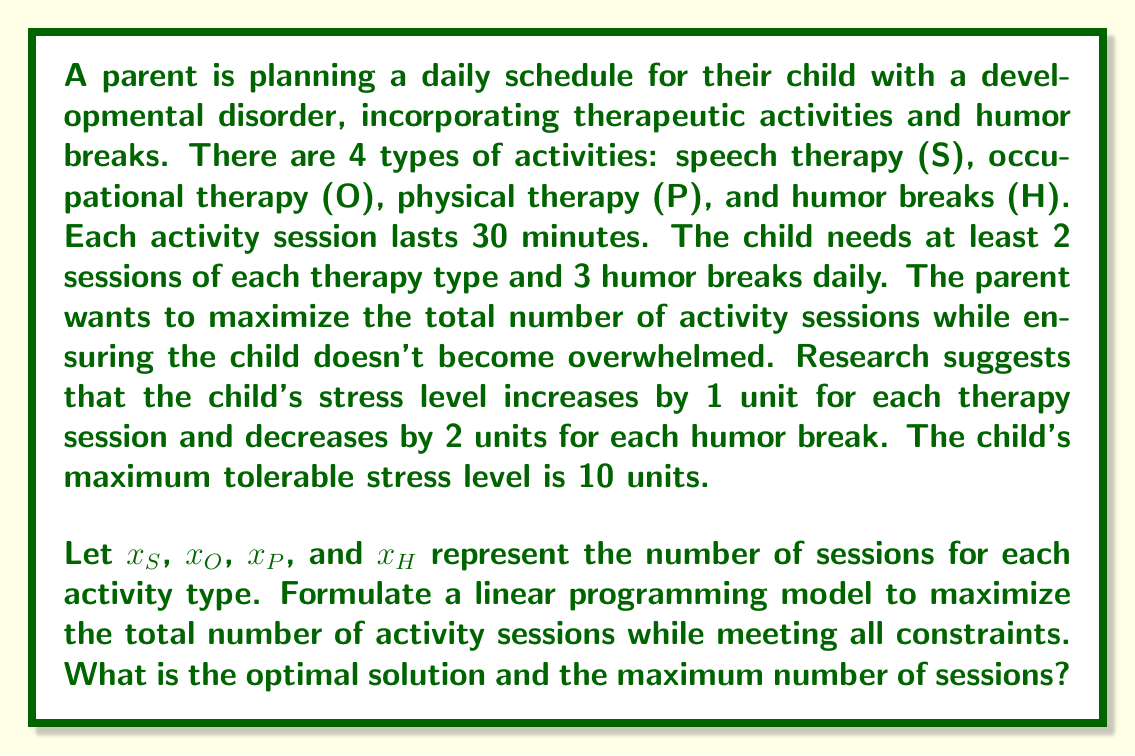Could you help me with this problem? To solve this problem, we need to set up a linear programming model:

Objective function:
Maximize $Z = x_S + x_O + x_P + x_H$

Subject to the following constraints:

1. Minimum sessions for each therapy type:
   $x_S \geq 2$
   $x_O \geq 2$
   $x_P \geq 2$

2. Minimum humor breaks:
   $x_H \geq 3$

3. Stress level constraint:
   $x_S + x_O + x_P - 2x_H \leq 10$

4. Non-negativity constraints:
   $x_S, x_O, x_P, x_H \geq 0$

To solve this, we can use the simplex method or a graphical approach. However, given the number of variables, we'll use a solver or software like Excel's Solver add-in.

The optimal solution is:
$x_S = 4$
$x_O = 4$
$x_P = 4$
$x_H = 5$

We can verify that this solution satisfies all constraints:
1. Each therapy type has at least 2 sessions.
2. There are 5 humor breaks, which is more than the required 3.
3. Stress level: $4 + 4 + 4 - 2(5) = 2 \leq 10$

The maximum number of sessions is the sum of all activities:
$Z = 4 + 4 + 4 + 5 = 17$
Answer: The optimal solution is $x_S = 4$, $x_O = 4$, $x_P = 4$, and $x_H = 5$, with a maximum of 17 total activity sessions. 